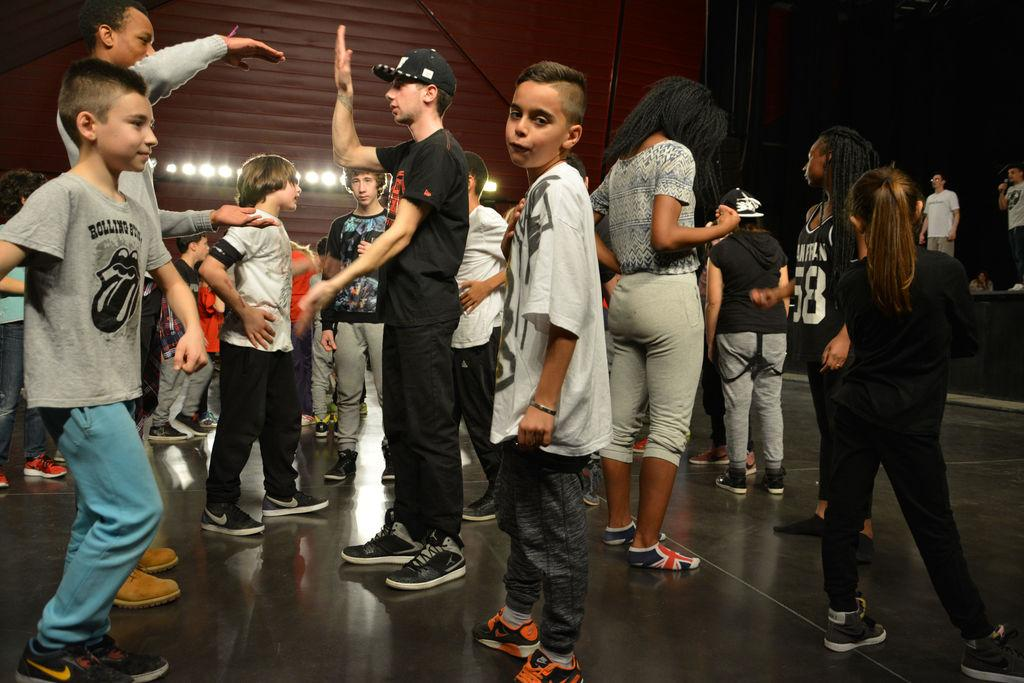How many people are in the image? There is a group of people in the image. What are the people wearing on their feet? The people are wearing shoes. Where are the people standing? The people are standing on the floor. What can be seen in the background of the image? There are lights and a wall in the background of the image, as well as additional people. What type of middle does the group of people regret in the image? There is no mention of regret or a middle in the image; it simply shows a group of people standing on the floor. 